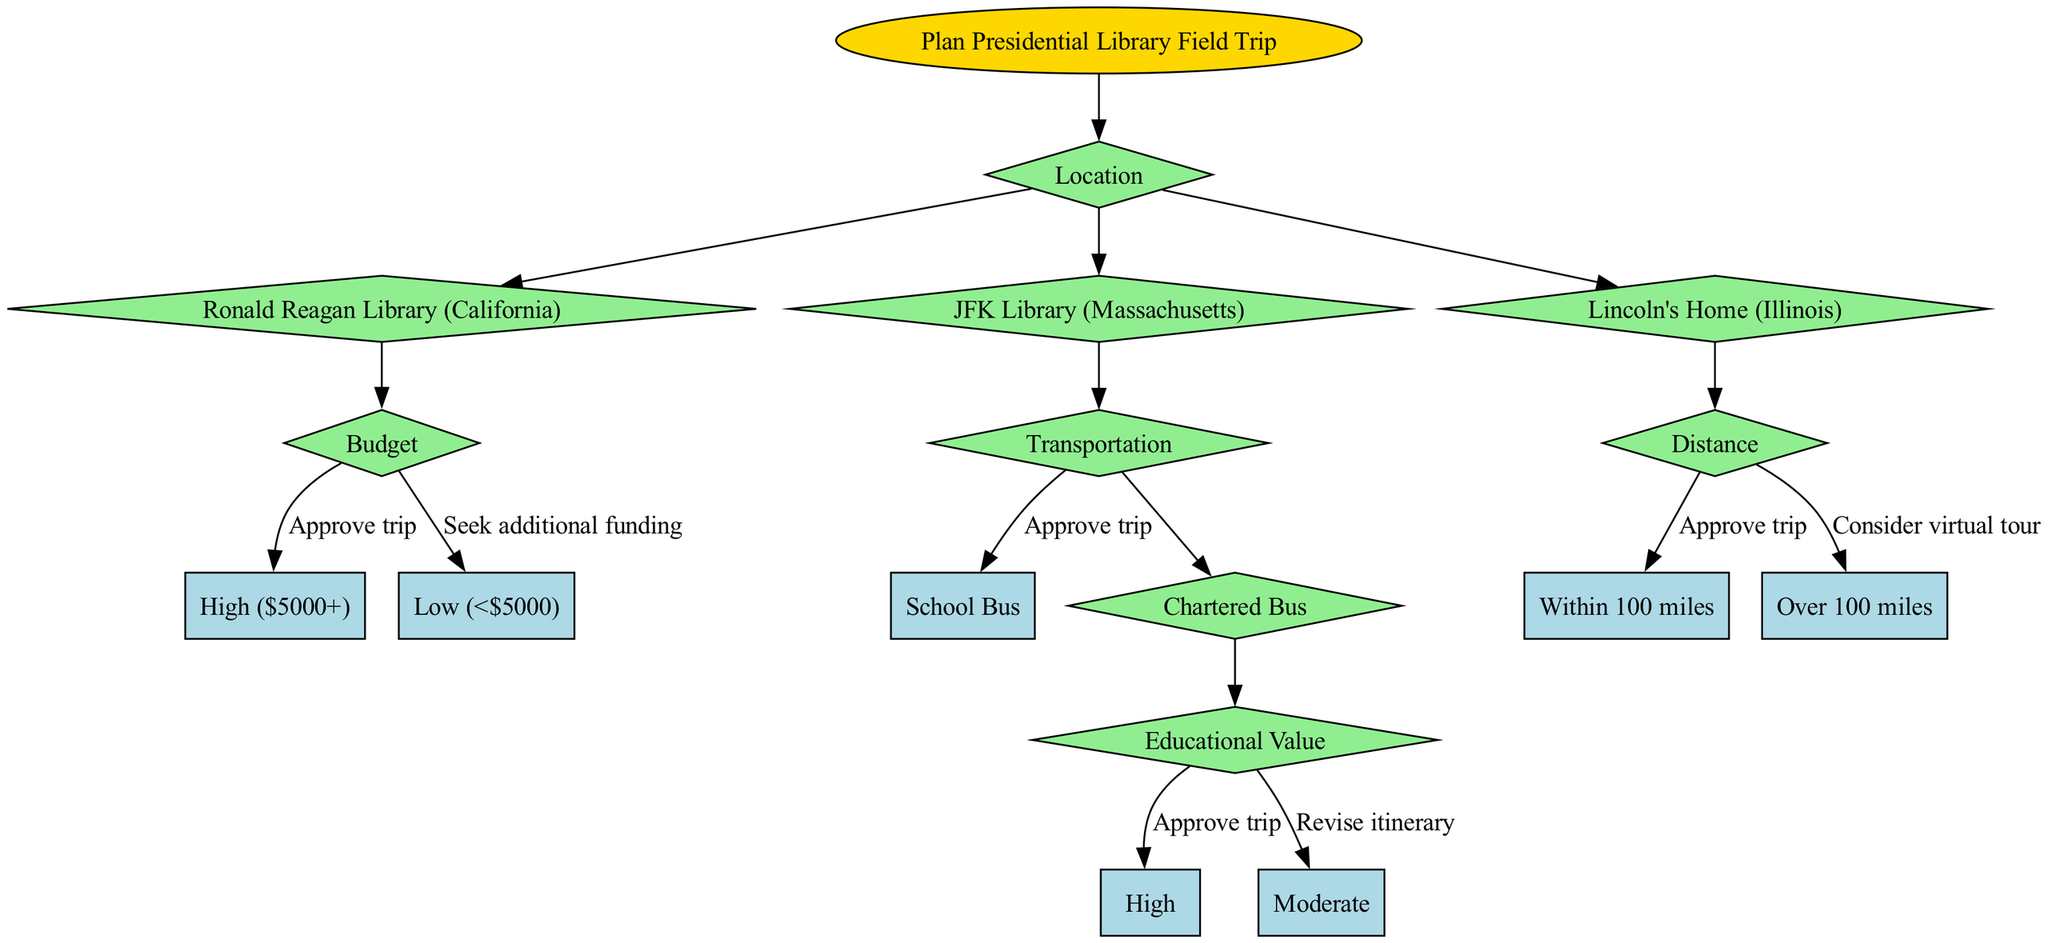What is the first decision point in the diagram? The root node states the first decision point is "Plan Presidential Library Field Trip." This is where the decision-making process starts regarding the location of the trip.
Answer: Plan Presidential Library Field Trip How many options are available for the location decision? The diagram shows three options under the "Location" decision: Ronald Reagan Library, JFK Library, and Lincoln's Home. Counting these options gives a total of three.
Answer: 3 What is the outcome if the budget for the Ronald Reagan Library is high? According to the decision tree, if the budget is classified as "High ($5000+)," the outcome will be "Approve trip." Thus, no further considerations are needed after that decision.
Answer: Approve trip What decision follows after choosing JFK Library if transportation is by school bus? In this scenario, choosing the JFK Library leads to the transportation decision, and selecting "School Bus" directly results in "Approve trip," meaning the trip would be sanctioned without further steps.
Answer: Approve trip What happens if the educational value for a chartered bus trip to the JFK Library is moderate? With a moderate educational value, the next step indicates "Revise itinerary," suggesting that adjustments to the planned activities must be made before approval can continue.
Answer: Revise itinerary What is the decision based on distance when planning a trip to Lincoln's Home? The decision regarding distance presents two options: if the distance is "Within 100 miles," the result is "Approve trip," while if it is "Over 100 miles," the instruction is to "Consider virtual tour." Therefore, the consideration is based solely on the distance traveled to Lincoln's Home.
Answer: Approve trip or Consider virtual tour What type of transportation leads to a decision based on educational value? Choosing "Chartered Bus" for transportation from the JFK Library leads to a subsequent decision regarding its educational value. This decision highlights the importance of educational aspects in selecting transportation options for the field trip.
Answer: Chartered Bus How are outcomes determined at each decision node? Outcomes at decision nodes are determined based on the options chosen at preceding nodes. Each decision leads to specific outcomes which guide whether to approve the trip, seek funding, or revise plans, integrating various factors such as budget, transportation, and educational value.
Answer: By chosen options 